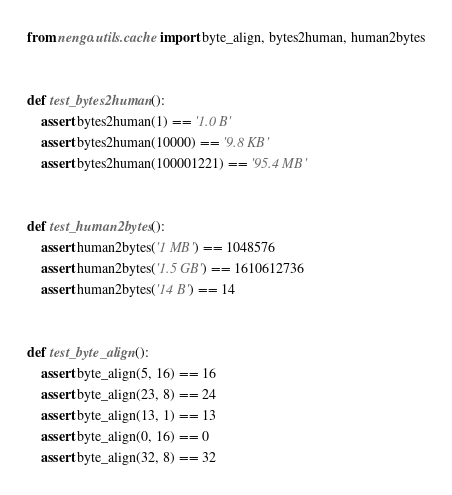Convert code to text. <code><loc_0><loc_0><loc_500><loc_500><_Python_>from nengo.utils.cache import byte_align, bytes2human, human2bytes


def test_bytes2human():
    assert bytes2human(1) == '1.0 B'
    assert bytes2human(10000) == '9.8 KB'
    assert bytes2human(100001221) == '95.4 MB'


def test_human2bytes():
    assert human2bytes('1 MB') == 1048576
    assert human2bytes('1.5 GB') == 1610612736
    assert human2bytes('14 B') == 14


def test_byte_align():
    assert byte_align(5, 16) == 16
    assert byte_align(23, 8) == 24
    assert byte_align(13, 1) == 13
    assert byte_align(0, 16) == 0
    assert byte_align(32, 8) == 32
</code> 